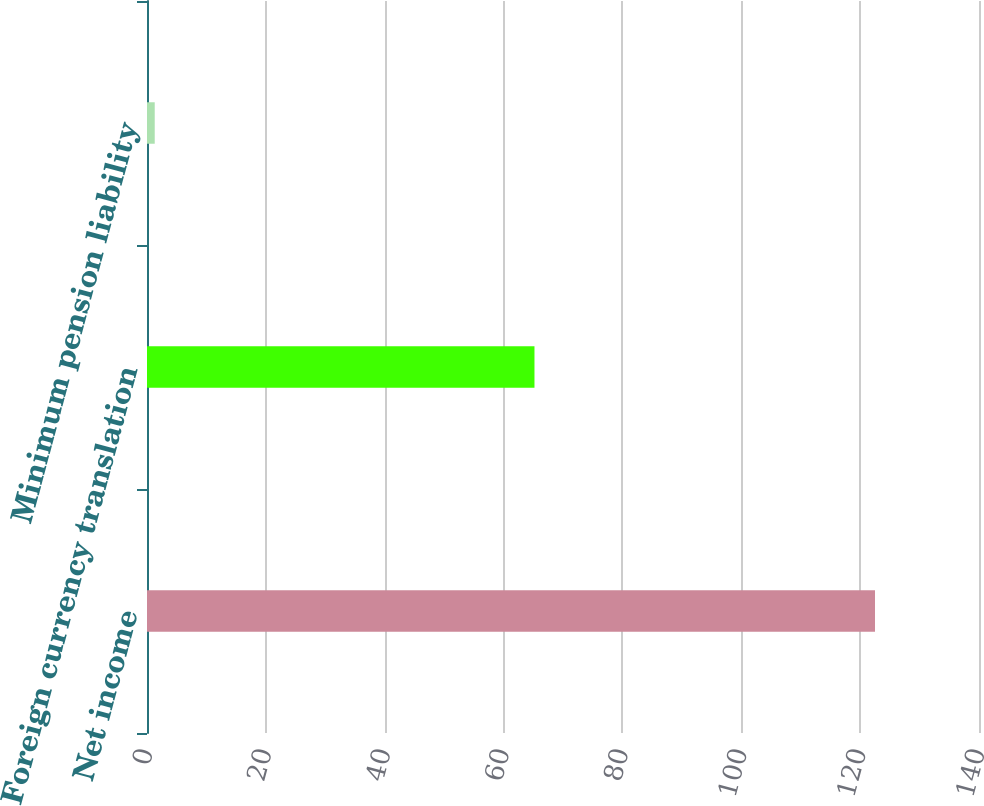Convert chart to OTSL. <chart><loc_0><loc_0><loc_500><loc_500><bar_chart><fcel>Net income<fcel>Foreign currency translation<fcel>Minimum pension liability<nl><fcel>122.5<fcel>65.2<fcel>1.3<nl></chart> 